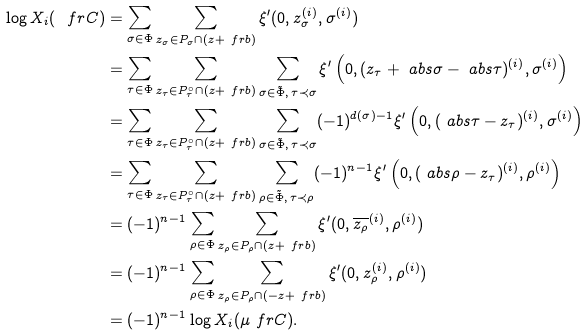<formula> <loc_0><loc_0><loc_500><loc_500>\log X _ { i } ( \ f r C ) & = \sum _ { \sigma \in \Phi } \sum _ { z _ { \sigma } \in P _ { \sigma } \cap ( z + \ f r b ) } \xi ^ { \prime } ( 0 , z _ { \sigma } ^ { ( i ) } , \sigma ^ { ( i ) } ) \\ & = \sum _ { \tau \in \Phi } \sum _ { z _ { \tau } \in P _ { \tau } ^ { \circ } \cap ( z + \ f r b ) } \sum _ { \sigma \in \tilde { \Phi } , \, \tau \prec \sigma } \xi ^ { \prime } \left ( 0 , ( z _ { \tau } + \ a b s { \sigma } - \ a b s { \tau } ) ^ { ( i ) } , \sigma ^ { ( i ) } \right ) \\ & = \sum _ { \tau \in \Phi } \sum _ { z _ { \tau } \in P _ { \tau } ^ { \circ } \cap ( z + \ f r b ) } \sum _ { \sigma \in \tilde { \Phi } , \, \tau \prec \sigma } ( - 1 ) ^ { d ( \sigma ) - 1 } \xi ^ { \prime } \left ( 0 , ( \ a b s { \tau } - z _ { \tau } ) ^ { ( i ) } , \sigma ^ { ( i ) } \right ) \\ & = \sum _ { \tau \in \Phi } \sum _ { z _ { \tau } \in P _ { \tau } ^ { \circ } \cap ( z + \ f r b ) } \sum _ { \rho \in \tilde { \Phi } , \, \tau \prec \rho } ( - 1 ) ^ { n - 1 } \xi ^ { \prime } \left ( 0 , ( \ a b s { \rho } - z _ { \tau } ) ^ { ( i ) } , \rho ^ { ( i ) } \right ) \\ & = ( - 1 ) ^ { n - 1 } \sum _ { \rho \in \Phi } \sum _ { z _ { \rho } \in P _ { \rho } \cap ( z + \ f r b ) } \xi ^ { \prime } ( 0 , \overline { z _ { \rho } } ^ { ( i ) } , \rho ^ { ( i ) } ) \\ & = ( - 1 ) ^ { n - 1 } \sum _ { \rho \in \Phi } \sum _ { z _ { \rho } \in P _ { \rho } \cap ( - z + \ f r b ) } \xi ^ { \prime } ( 0 , z _ { \rho } ^ { ( i ) } , \rho ^ { ( i ) } ) \\ & = ( - 1 ) ^ { n - 1 } \log X _ { i } ( \mu \ f r C ) .</formula> 